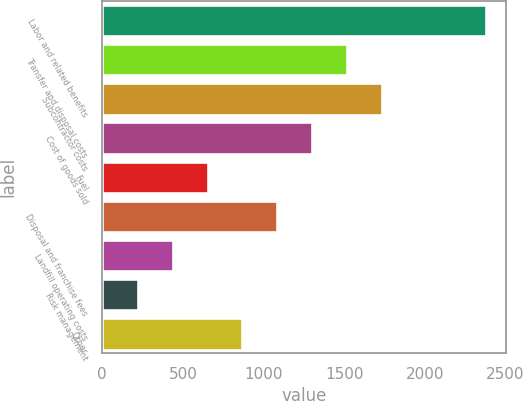Convert chart to OTSL. <chart><loc_0><loc_0><loc_500><loc_500><bar_chart><fcel>Labor and related benefits<fcel>Transfer and disposal costs<fcel>Subcontractor costs<fcel>Cost of goods sold<fcel>Fuel<fcel>Disposal and franchise fees<fcel>Landfill operating costs<fcel>Risk management<fcel>Other<nl><fcel>2381<fcel>1517<fcel>1733<fcel>1301<fcel>653<fcel>1085<fcel>437<fcel>221<fcel>869<nl></chart> 